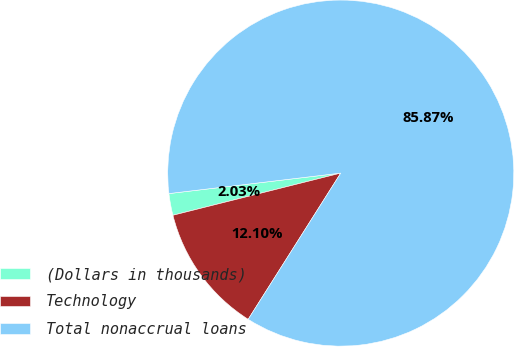<chart> <loc_0><loc_0><loc_500><loc_500><pie_chart><fcel>(Dollars in thousands)<fcel>Technology<fcel>Total nonaccrual loans<nl><fcel>2.03%<fcel>12.1%<fcel>85.87%<nl></chart> 